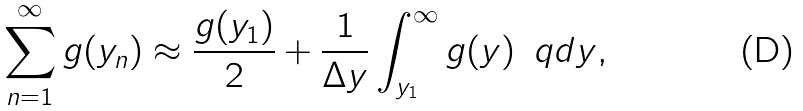<formula> <loc_0><loc_0><loc_500><loc_500>\sum _ { n = 1 } ^ { \infty } g ( y _ { n } ) \approx \frac { g ( y _ { 1 } ) } { 2 } + \frac { 1 } { \Delta y } \int _ { y _ { 1 } } ^ { \infty } g ( y ) \, \ q d y ,</formula> 